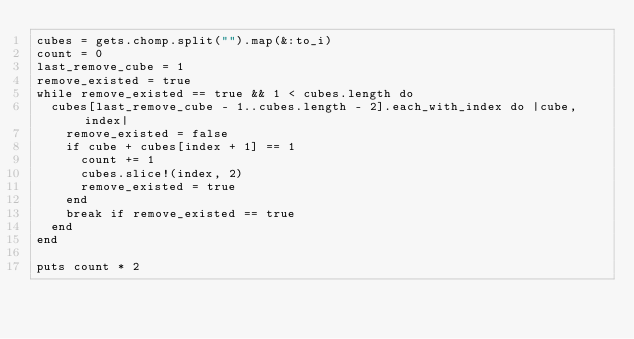Convert code to text. <code><loc_0><loc_0><loc_500><loc_500><_Ruby_>cubes = gets.chomp.split("").map(&:to_i)
count = 0
last_remove_cube = 1
remove_existed = true
while remove_existed == true && 1 < cubes.length do
  cubes[last_remove_cube - 1..cubes.length - 2].each_with_index do |cube, index|
    remove_existed = false
    if cube + cubes[index + 1] == 1
      count += 1
      cubes.slice!(index, 2)
      remove_existed = true
    end
    break if remove_existed == true
  end
end

puts count * 2</code> 